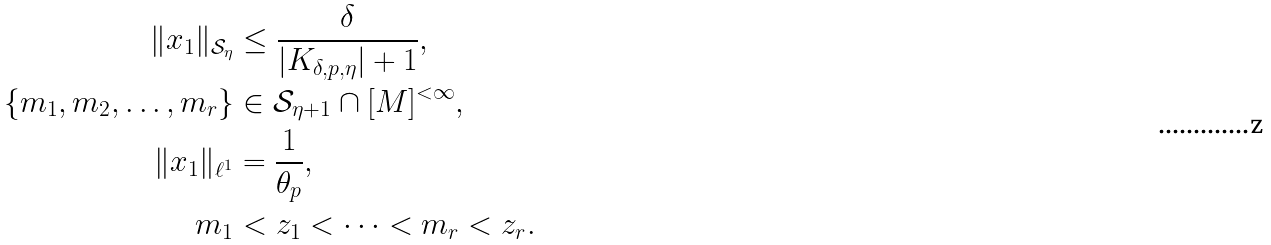Convert formula to latex. <formula><loc_0><loc_0><loc_500><loc_500>\| x _ { 1 } \| _ { \mathcal { S } _ { \eta } } & \leq \frac { \delta } { | K _ { \delta , p , \eta } | + 1 } , \\ \{ m _ { 1 } , m _ { 2 } , \dots , m _ { r } \} & \in \mathcal { S } _ { \eta + 1 } \cap [ M ] ^ { < \infty } , \\ \| x _ { 1 } \| _ { \ell ^ { 1 } } & = \frac { 1 } { \theta _ { p } } , \\ m _ { 1 } & < z _ { 1 } < \dots < m _ { r } < z _ { r } .</formula> 